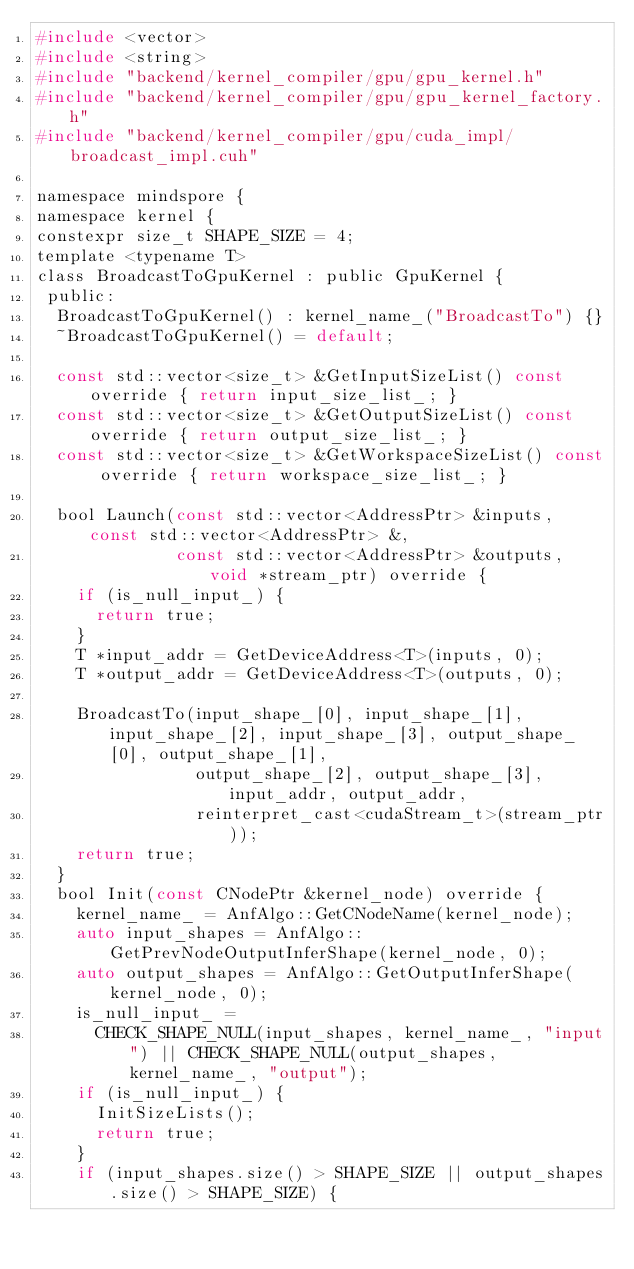Convert code to text. <code><loc_0><loc_0><loc_500><loc_500><_C_>#include <vector>
#include <string>
#include "backend/kernel_compiler/gpu/gpu_kernel.h"
#include "backend/kernel_compiler/gpu/gpu_kernel_factory.h"
#include "backend/kernel_compiler/gpu/cuda_impl/broadcast_impl.cuh"

namespace mindspore {
namespace kernel {
constexpr size_t SHAPE_SIZE = 4;
template <typename T>
class BroadcastToGpuKernel : public GpuKernel {
 public:
  BroadcastToGpuKernel() : kernel_name_("BroadcastTo") {}
  ~BroadcastToGpuKernel() = default;

  const std::vector<size_t> &GetInputSizeList() const override { return input_size_list_; }
  const std::vector<size_t> &GetOutputSizeList() const override { return output_size_list_; }
  const std::vector<size_t> &GetWorkspaceSizeList() const override { return workspace_size_list_; }

  bool Launch(const std::vector<AddressPtr> &inputs, const std::vector<AddressPtr> &,
              const std::vector<AddressPtr> &outputs, void *stream_ptr) override {
    if (is_null_input_) {
      return true;
    }
    T *input_addr = GetDeviceAddress<T>(inputs, 0);
    T *output_addr = GetDeviceAddress<T>(outputs, 0);

    BroadcastTo(input_shape_[0], input_shape_[1], input_shape_[2], input_shape_[3], output_shape_[0], output_shape_[1],
                output_shape_[2], output_shape_[3], input_addr, output_addr,
                reinterpret_cast<cudaStream_t>(stream_ptr));
    return true;
  }
  bool Init(const CNodePtr &kernel_node) override {
    kernel_name_ = AnfAlgo::GetCNodeName(kernel_node);
    auto input_shapes = AnfAlgo::GetPrevNodeOutputInferShape(kernel_node, 0);
    auto output_shapes = AnfAlgo::GetOutputInferShape(kernel_node, 0);
    is_null_input_ =
      CHECK_SHAPE_NULL(input_shapes, kernel_name_, "input") || CHECK_SHAPE_NULL(output_shapes, kernel_name_, "output");
    if (is_null_input_) {
      InitSizeLists();
      return true;
    }
    if (input_shapes.size() > SHAPE_SIZE || output_shapes.size() > SHAPE_SIZE) {</code> 